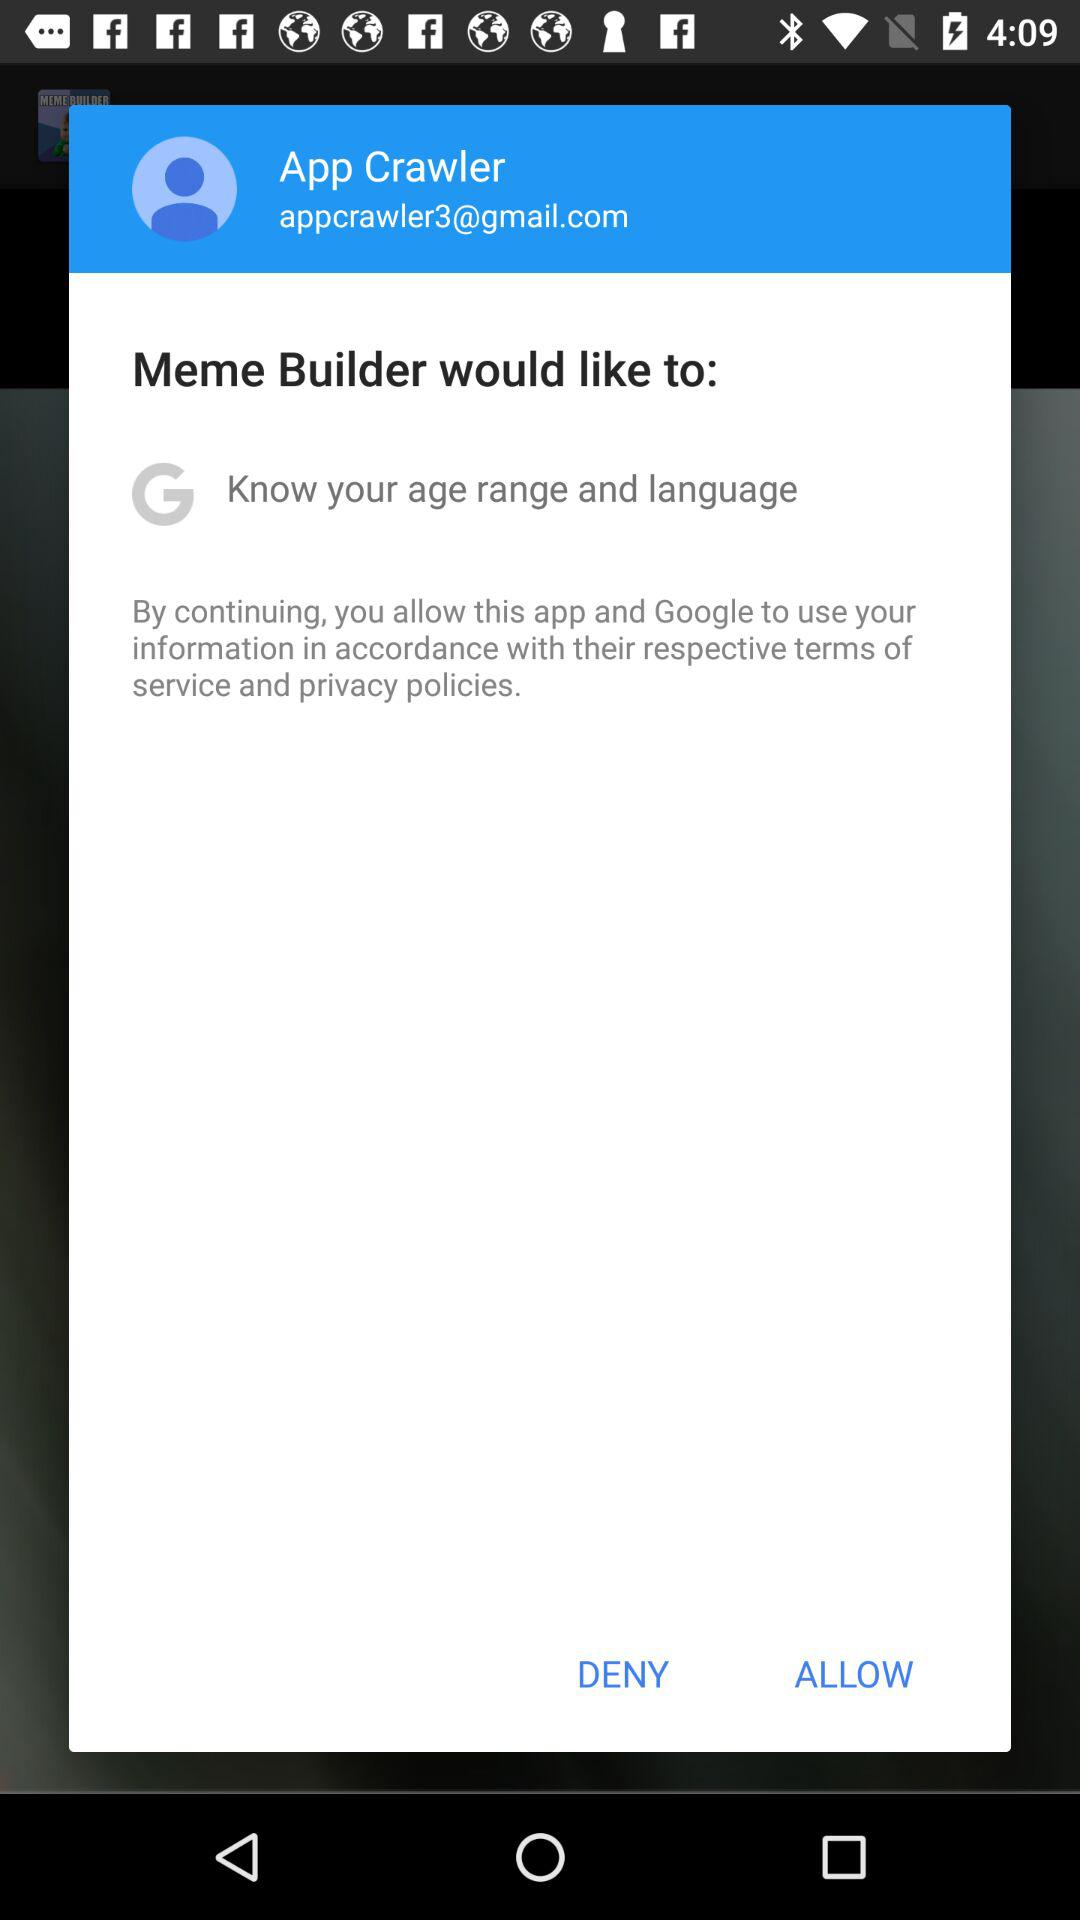Which application would like to know the age range and language? The application who would like to know the age range and language is "Meme Builder". 